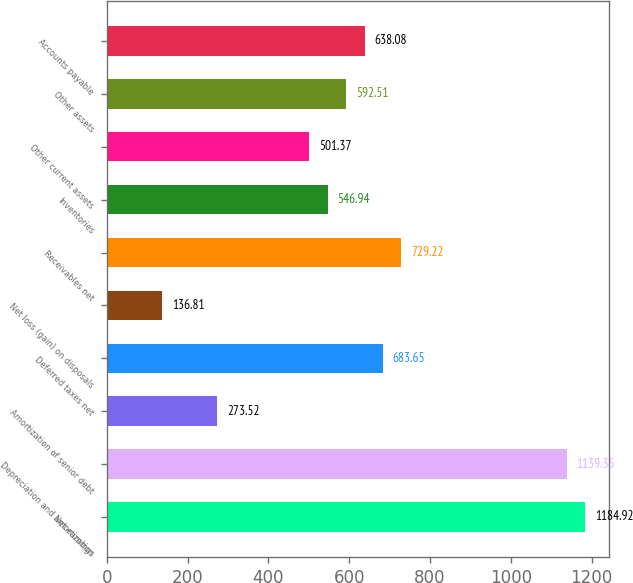Convert chart to OTSL. <chart><loc_0><loc_0><loc_500><loc_500><bar_chart><fcel>Net earnings<fcel>Depreciation and amortization<fcel>Amortization of senior debt<fcel>Deferred taxes net<fcel>Net loss (gain) on disposals<fcel>Receivables net<fcel>Inventories<fcel>Other current assets<fcel>Other assets<fcel>Accounts payable<nl><fcel>1184.92<fcel>1139.35<fcel>273.52<fcel>683.65<fcel>136.81<fcel>729.22<fcel>546.94<fcel>501.37<fcel>592.51<fcel>638.08<nl></chart> 